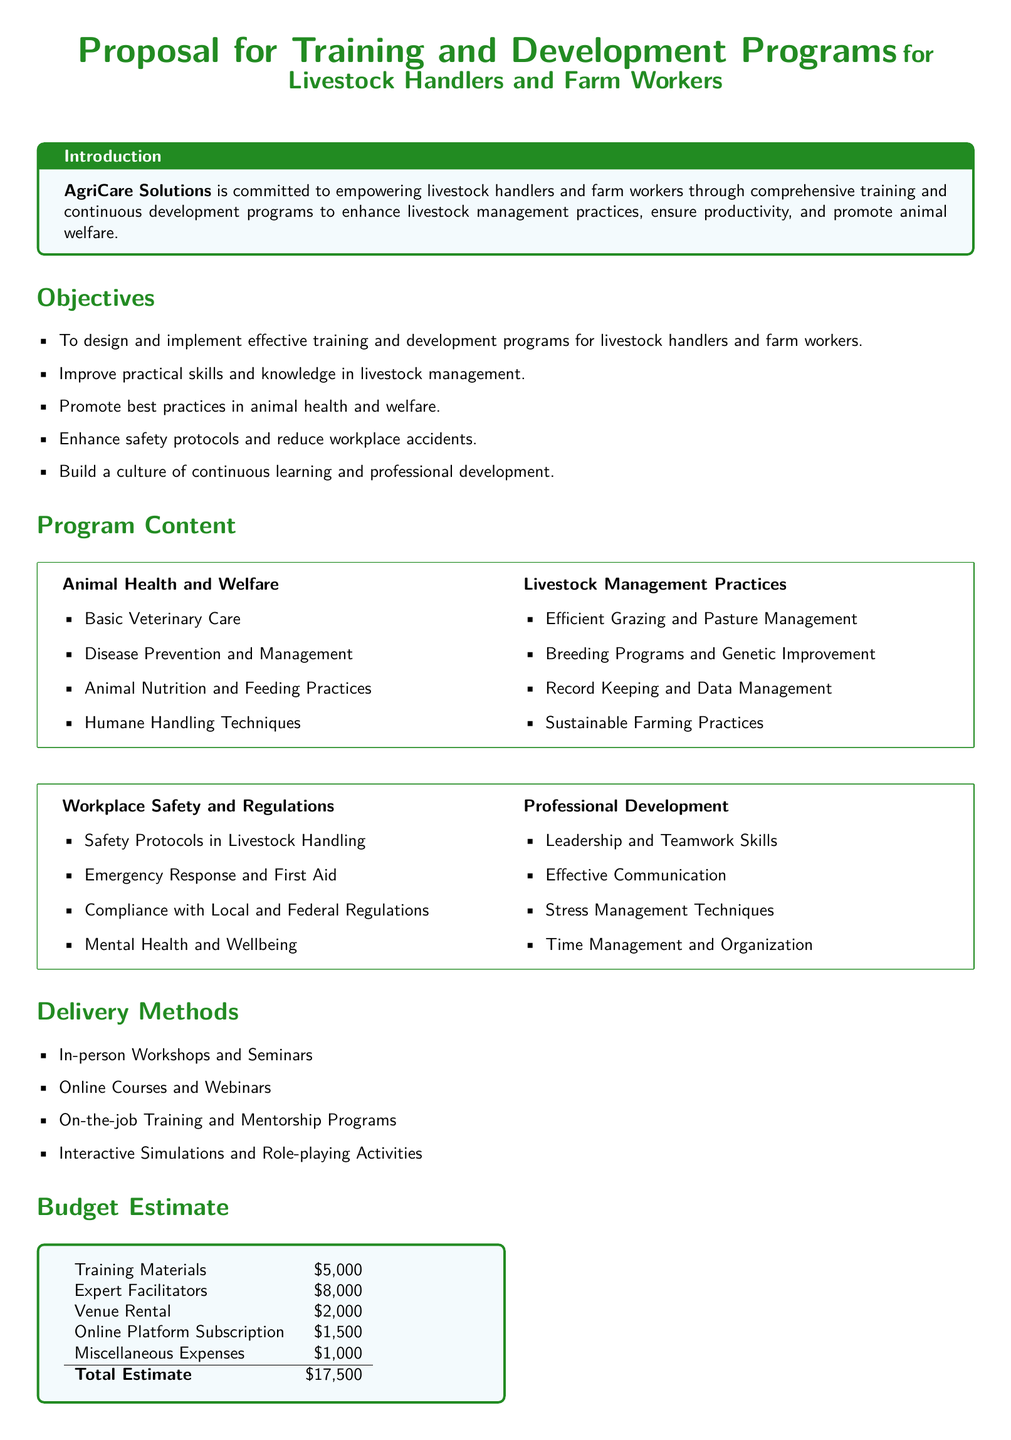what is the total budget estimate? The total budget estimate is the sum of all individual costs listed in the document, which totals $5,000 + $8,000 + $2,000 + $1,500 + $1,000.
Answer: $17,500 who is committed to empowering livestock handlers? The document states that AgriCare Solutions is committed to empowering livestock handlers and farm workers.
Answer: AgriCare Solutions what is one of the objectives of the training program? The document lists several objectives, including improving practical skills and knowledge in livestock management as one of them.
Answer: Improve practical skills and knowledge in livestock management name one delivery method mentioned in the proposal. The document specifies several delivery methods, including in-person workshops and seminars as one of them.
Answer: In-person Workshops and Seminars how much is allocated for expert facilitators? The budget estimate details the cost allocated for expert facilitators in the training program.
Answer: $8,000 what is a topic covered under Animal Health and Welfare? The document lists basic veterinary care as one of the topics covered under Animal Health and Welfare.
Answer: Basic Veterinary Care which skill is targeted for professional development? The document mentions effective communication as a skill targeted for professional development.
Answer: Effective Communication what is the aim of the proposed training programs? The document concludes that the proposed training programs aim to provide essential skills and knowledge for livestock handlers and farm workers.
Answer: Provide essential skills and knowledge what type of approach does the proposal suggest for continuous learning? The proposal includes building a culture of continuous learning and professional development as part of the objectives.
Answer: Continuous learning and professional development 